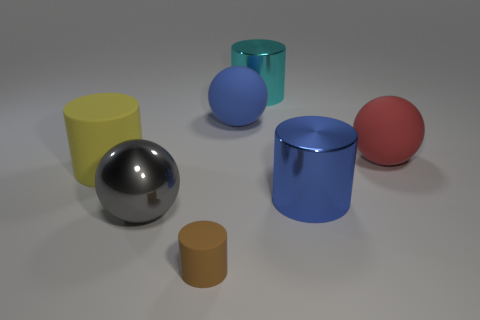Is there any other thing that has the same color as the big rubber cylinder?
Your response must be concise. No. Are there fewer big cylinders that are right of the brown rubber thing than rubber objects?
Offer a very short reply. Yes. How many other cyan cylinders have the same size as the cyan shiny cylinder?
Keep it short and to the point. 0. There is a cyan thing that is behind the ball that is to the right of the large cylinder that is behind the big yellow matte thing; what shape is it?
Your answer should be compact. Cylinder. There is a big rubber ball to the left of the large cyan metal cylinder; what is its color?
Offer a terse response. Blue. What number of objects are matte cylinders that are in front of the large blue metallic thing or large objects that are left of the brown thing?
Provide a short and direct response. 3. What number of big blue things are the same shape as the small thing?
Provide a succinct answer. 1. There is a metal ball that is the same size as the yellow matte thing; what color is it?
Give a very brief answer. Gray. There is a big cylinder that is behind the thing that is to the left of the ball that is to the left of the small brown matte thing; what is its color?
Your response must be concise. Cyan. Do the yellow object and the metal cylinder in front of the big red matte thing have the same size?
Provide a succinct answer. Yes. 